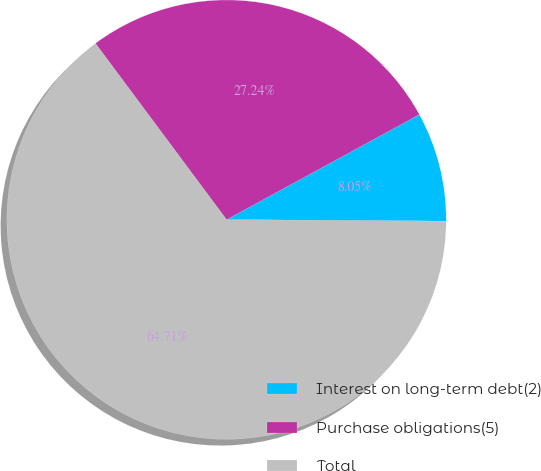Convert chart. <chart><loc_0><loc_0><loc_500><loc_500><pie_chart><fcel>Interest on long-term debt(2)<fcel>Purchase obligations(5)<fcel>Total<nl><fcel>8.05%<fcel>27.24%<fcel>64.72%<nl></chart> 